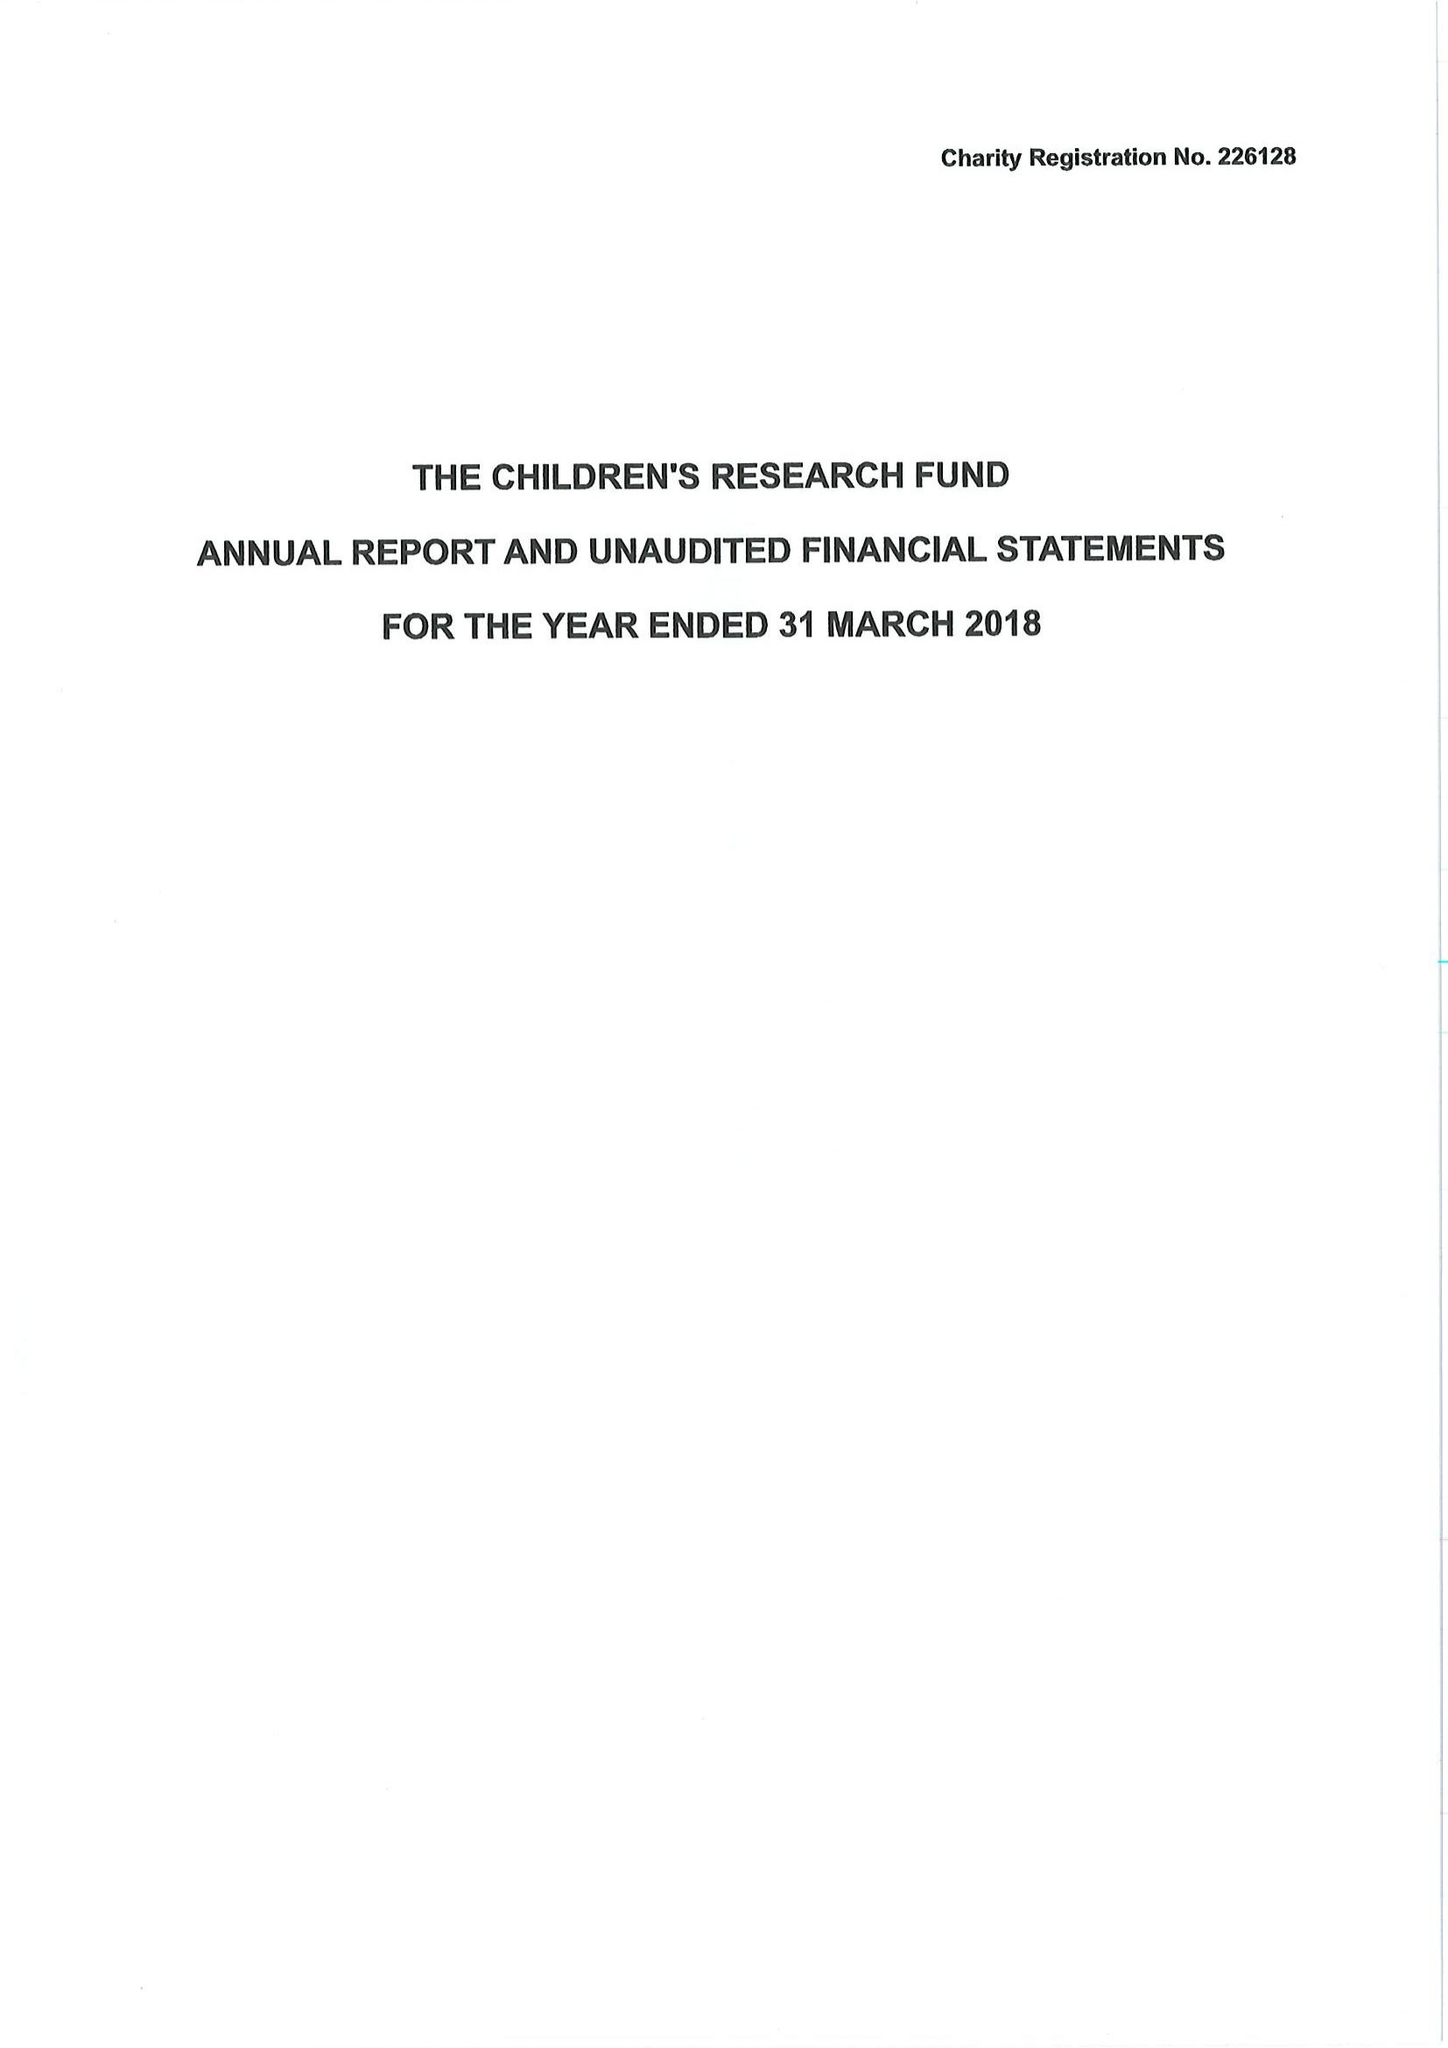What is the value for the address__post_town?
Answer the question using a single word or phrase. RUTHIN 